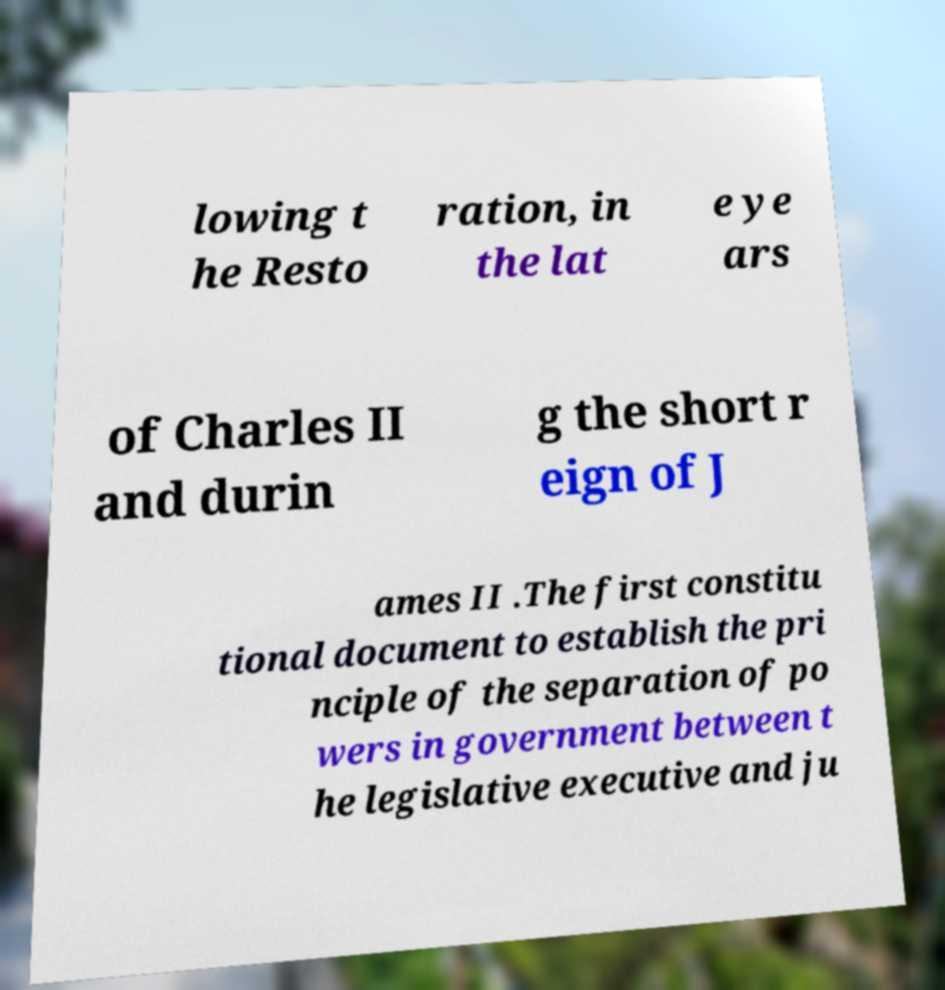For documentation purposes, I need the text within this image transcribed. Could you provide that? lowing t he Resto ration, in the lat e ye ars of Charles II and durin g the short r eign of J ames II .The first constitu tional document to establish the pri nciple of the separation of po wers in government between t he legislative executive and ju 